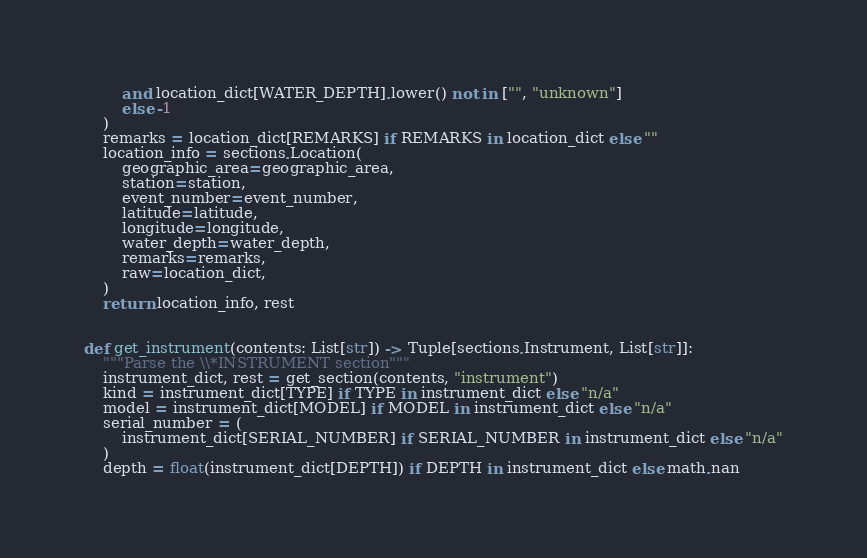<code> <loc_0><loc_0><loc_500><loc_500><_Python_>        and location_dict[WATER_DEPTH].lower() not in ["", "unknown"]
        else -1
    )
    remarks = location_dict[REMARKS] if REMARKS in location_dict else ""
    location_info = sections.Location(
        geographic_area=geographic_area,
        station=station,
        event_number=event_number,
        latitude=latitude,
        longitude=longitude,
        water_depth=water_depth,
        remarks=remarks,
        raw=location_dict,
    )
    return location_info, rest


def get_instrument(contents: List[str]) -> Tuple[sections.Instrument, List[str]]:
    """Parse the \\*INSTRUMENT section"""
    instrument_dict, rest = get_section(contents, "instrument")
    kind = instrument_dict[TYPE] if TYPE in instrument_dict else "n/a"
    model = instrument_dict[MODEL] if MODEL in instrument_dict else "n/a"
    serial_number = (
        instrument_dict[SERIAL_NUMBER] if SERIAL_NUMBER in instrument_dict else "n/a"
    )
    depth = float(instrument_dict[DEPTH]) if DEPTH in instrument_dict else math.nan</code> 